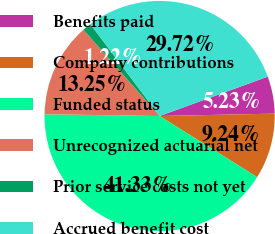Convert chart to OTSL. <chart><loc_0><loc_0><loc_500><loc_500><pie_chart><fcel>Benefits paid<fcel>Company contributions<fcel>Funded status<fcel>Unrecognized actuarial net<fcel>Prior service costs not yet<fcel>Accrued benefit cost<nl><fcel>5.23%<fcel>9.24%<fcel>41.33%<fcel>13.25%<fcel>1.22%<fcel>29.72%<nl></chart> 